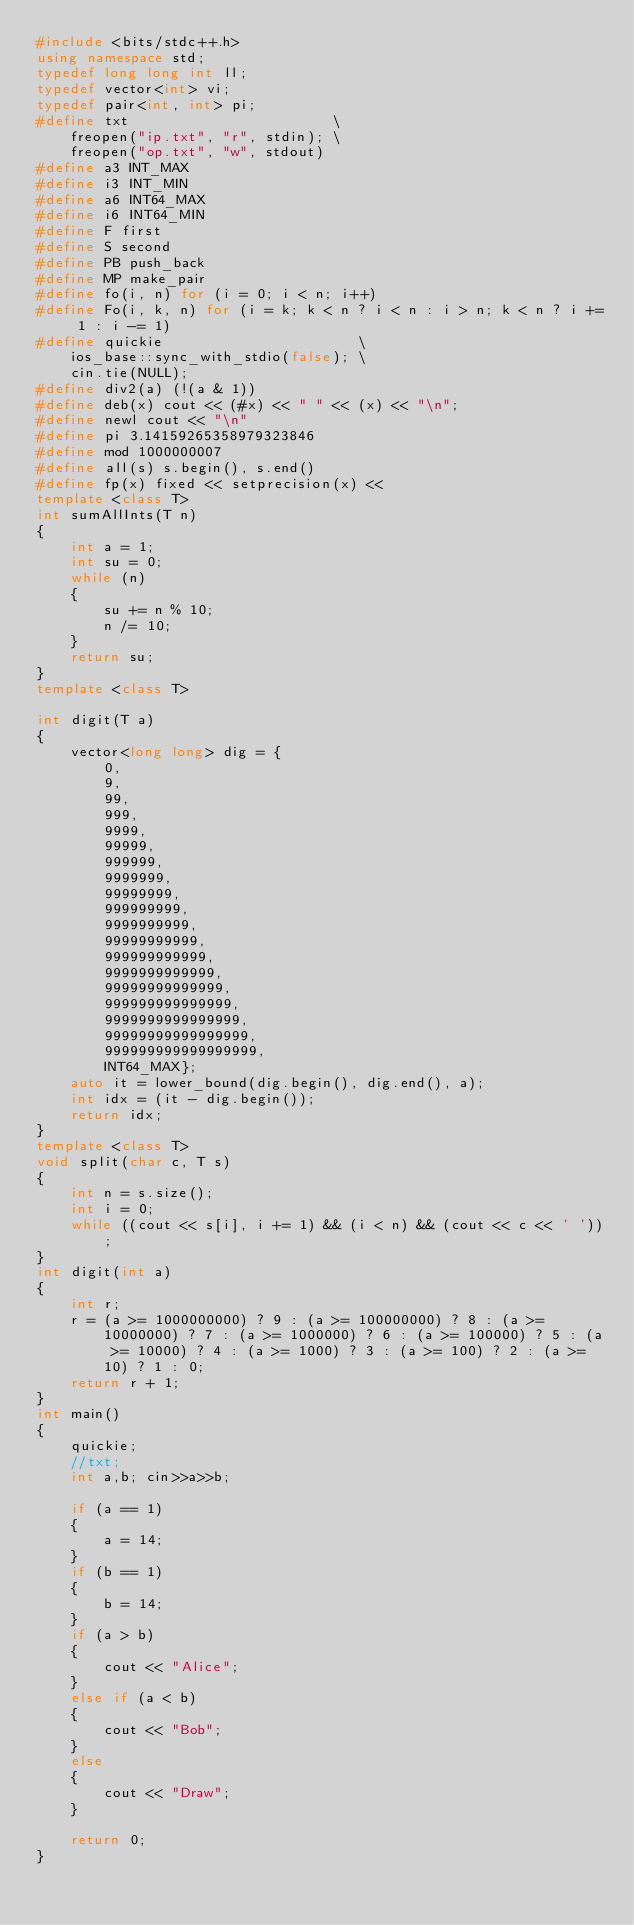<code> <loc_0><loc_0><loc_500><loc_500><_C++_>#include <bits/stdc++.h>
using namespace std;
typedef long long int ll;
typedef vector<int> vi;
typedef pair<int, int> pi;
#define txt                        \
    freopen("ip.txt", "r", stdin); \
    freopen("op.txt", "w", stdout)
#define a3 INT_MAX
#define i3 INT_MIN
#define a6 INT64_MAX
#define i6 INT64_MIN
#define F first
#define S second
#define PB push_back
#define MP make_pair
#define fo(i, n) for (i = 0; i < n; i++)
#define Fo(i, k, n) for (i = k; k < n ? i < n : i > n; k < n ? i += 1 : i -= 1)
#define quickie                       \
    ios_base::sync_with_stdio(false); \
    cin.tie(NULL);
#define div2(a) (!(a & 1))
#define deb(x) cout << (#x) << " " << (x) << "\n";
#define newl cout << "\n"
#define pi 3.14159265358979323846
#define mod 1000000007
#define all(s) s.begin(), s.end()
#define fp(x) fixed << setprecision(x) <<
template <class T>
int sumAllInts(T n)
{
    int a = 1;
    int su = 0;
    while (n)
    {
        su += n % 10;
        n /= 10;
    }
    return su;
}
template <class T>

int digit(T a)
{
    vector<long long> dig = {
        0,
        9,
        99,
        999,
        9999,
        99999,
        999999,
        9999999,
        99999999,
        999999999,
        9999999999,
        99999999999,
        999999999999,
        9999999999999,
        99999999999999,
        999999999999999,
        9999999999999999,
        99999999999999999,
        999999999999999999,
        INT64_MAX};
    auto it = lower_bound(dig.begin(), dig.end(), a);
    int idx = (it - dig.begin());
    return idx;
}
template <class T>
void split(char c, T s)
{
    int n = s.size();
    int i = 0;
    while ((cout << s[i], i += 1) && (i < n) && (cout << c << ' '))
        ;
}
int digit(int a)
{
    int r;
    r = (a >= 1000000000) ? 9 : (a >= 100000000) ? 8 : (a >= 10000000) ? 7 : (a >= 1000000) ? 6 : (a >= 100000) ? 5 : (a >= 10000) ? 4 : (a >= 1000) ? 3 : (a >= 100) ? 2 : (a >= 10) ? 1 : 0;
    return r + 1;
}
int main()
{
    quickie;
    //txt;
    int a,b; cin>>a>>b;

    if (a == 1)
    {
        a = 14;
    }
    if (b == 1)
    {
        b = 14;
    }
    if (a > b)
    {
        cout << "Alice";
    }
    else if (a < b)
    {
        cout << "Bob";
    }
    else
    {
        cout << "Draw";
    }

    return 0;
}</code> 